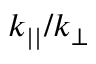Convert formula to latex. <formula><loc_0><loc_0><loc_500><loc_500>k _ { | | } / k _ { \perp }</formula> 